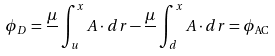<formula> <loc_0><loc_0><loc_500><loc_500>\phi _ { D } = \frac { \mu } { } \int _ { u } ^ { x } { A } \cdot d { r } - \frac { \mu } { } \int _ { d } ^ { x } { A } \cdot d { r } = \phi _ { { \text {AC} } }</formula> 